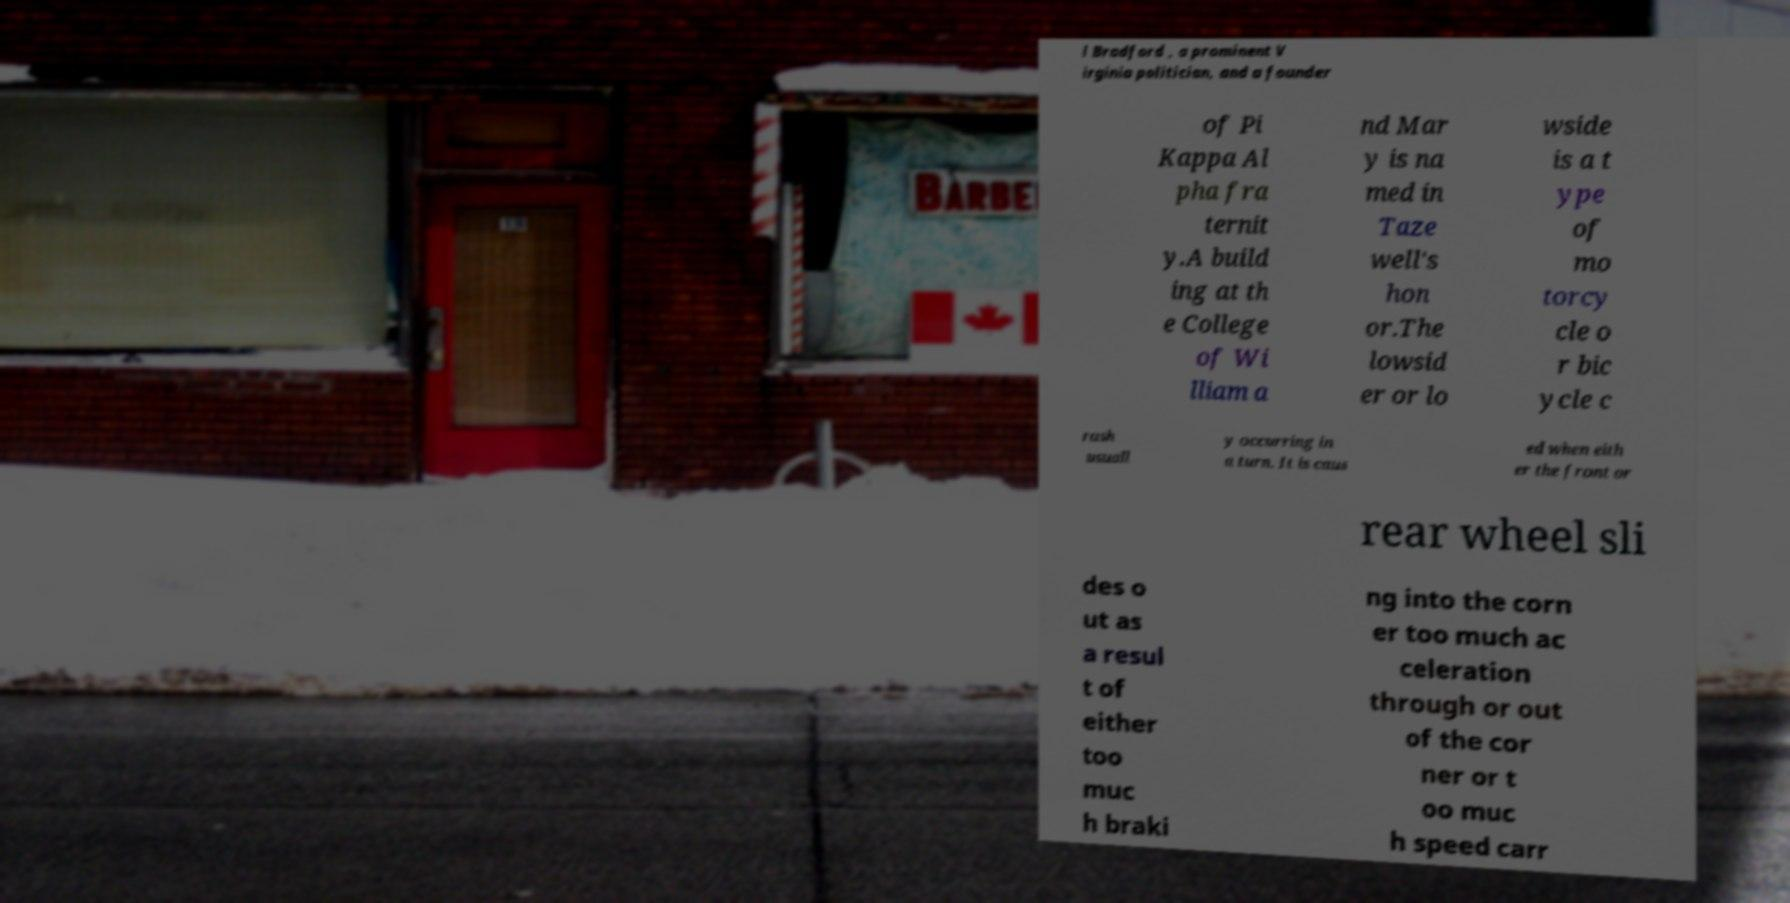I need the written content from this picture converted into text. Can you do that? l Bradford , a prominent V irginia politician, and a founder of Pi Kappa Al pha fra ternit y.A build ing at th e College of Wi lliam a nd Mar y is na med in Taze well's hon or.The lowsid er or lo wside is a t ype of mo torcy cle o r bic ycle c rash usuall y occurring in a turn. It is caus ed when eith er the front or rear wheel sli des o ut as a resul t of either too muc h braki ng into the corn er too much ac celeration through or out of the cor ner or t oo muc h speed carr 